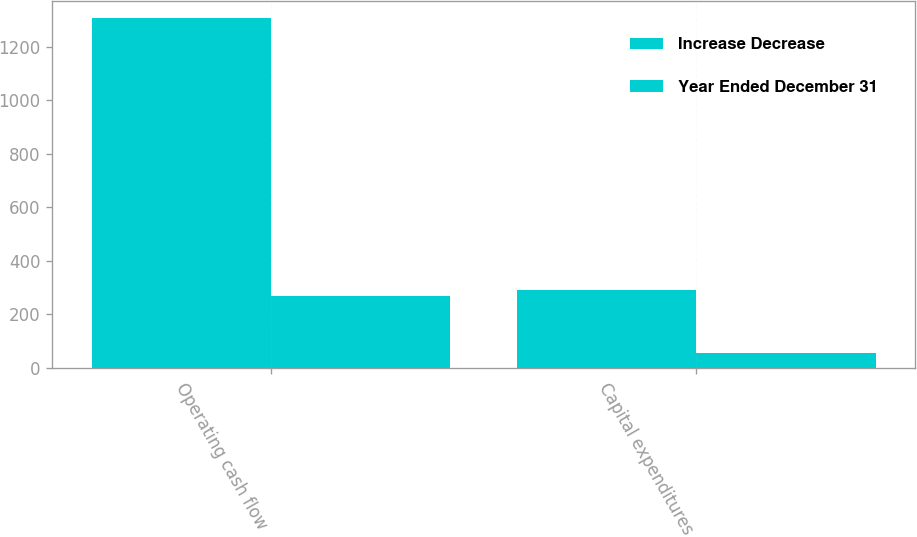Convert chart. <chart><loc_0><loc_0><loc_500><loc_500><stacked_bar_chart><ecel><fcel>Operating cash flow<fcel>Capital expenditures<nl><fcel>Increase Decrease<fcel>1307<fcel>292<nl><fcel>Year Ended December 31<fcel>268<fcel>56<nl></chart> 